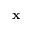Convert formula to latex. <formula><loc_0><loc_0><loc_500><loc_500>x</formula> 